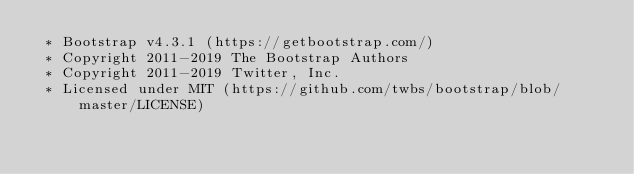<code> <loc_0><loc_0><loc_500><loc_500><_CSS_> * Bootstrap v4.3.1 (https://getbootstrap.com/)
 * Copyright 2011-2019 The Bootstrap Authors
 * Copyright 2011-2019 Twitter, Inc.
 * Licensed under MIT (https://github.com/twbs/bootstrap/blob/master/LICENSE)</code> 